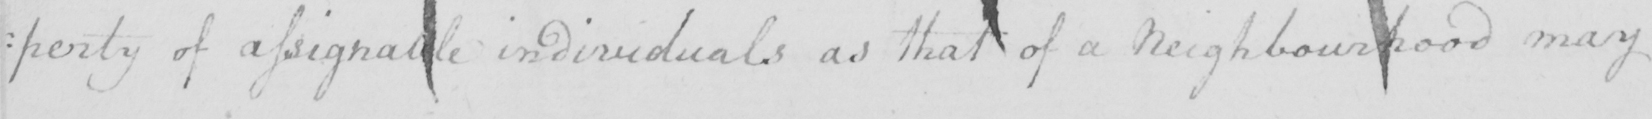Please provide the text content of this handwritten line. : perty of assignable individuals as that of a Neighbourhood may 